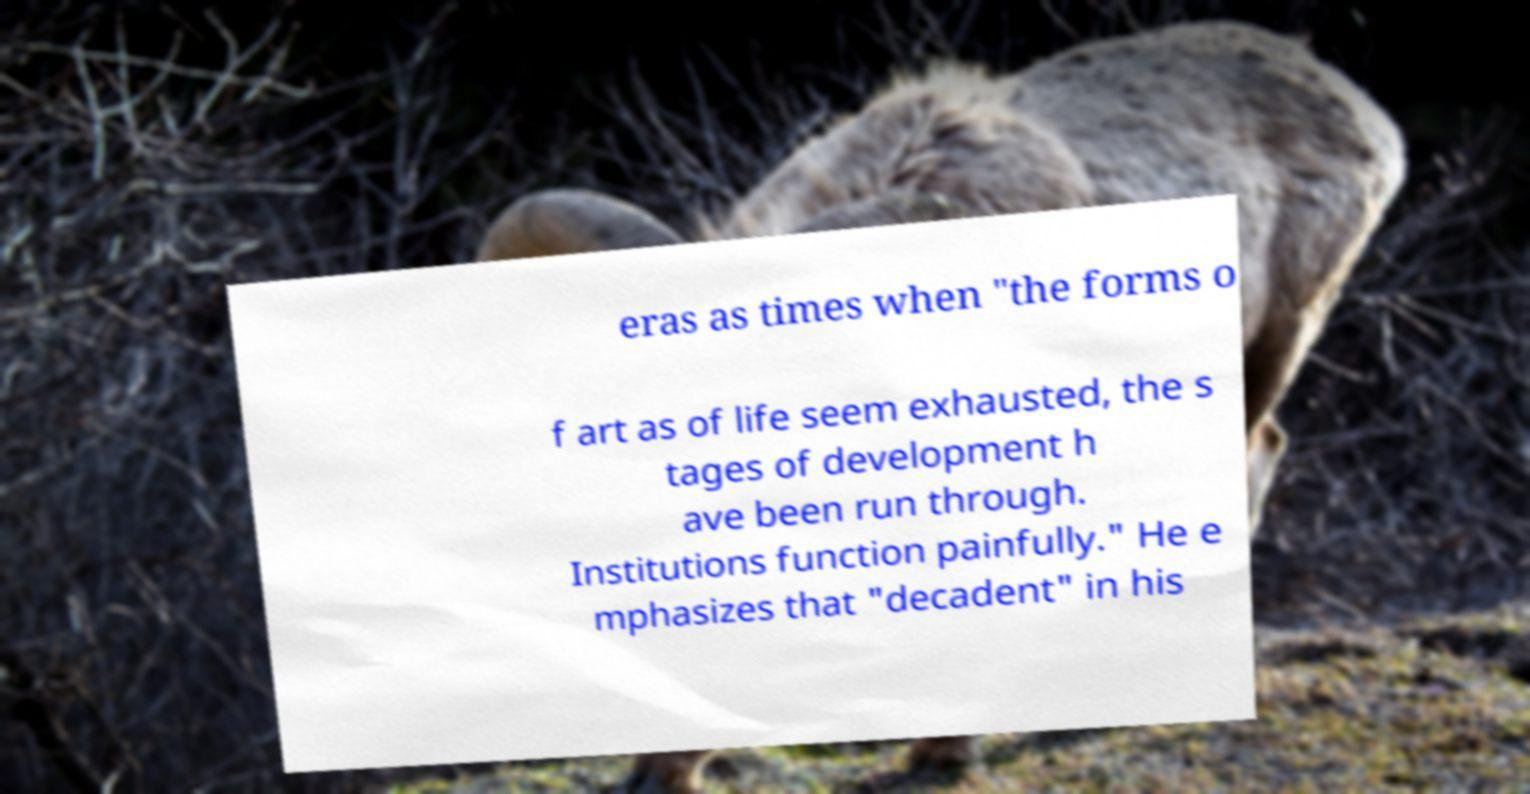Could you assist in decoding the text presented in this image and type it out clearly? eras as times when "the forms o f art as of life seem exhausted, the s tages of development h ave been run through. Institutions function painfully." He e mphasizes that "decadent" in his 